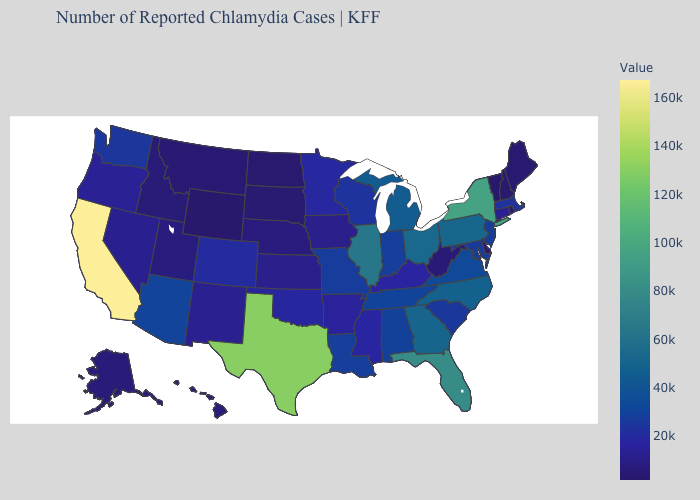Among the states that border Nebraska , which have the highest value?
Short answer required. Missouri. Among the states that border Illinois , does Indiana have the highest value?
Give a very brief answer. Yes. Which states have the lowest value in the Northeast?
Give a very brief answer. Vermont. Does Vermont have the lowest value in the USA?
Concise answer only. Yes. Does Illinois have the highest value in the MidWest?
Quick response, please. Yes. Does the map have missing data?
Quick response, please. No. Among the states that border Rhode Island , does Massachusetts have the highest value?
Write a very short answer. Yes. 